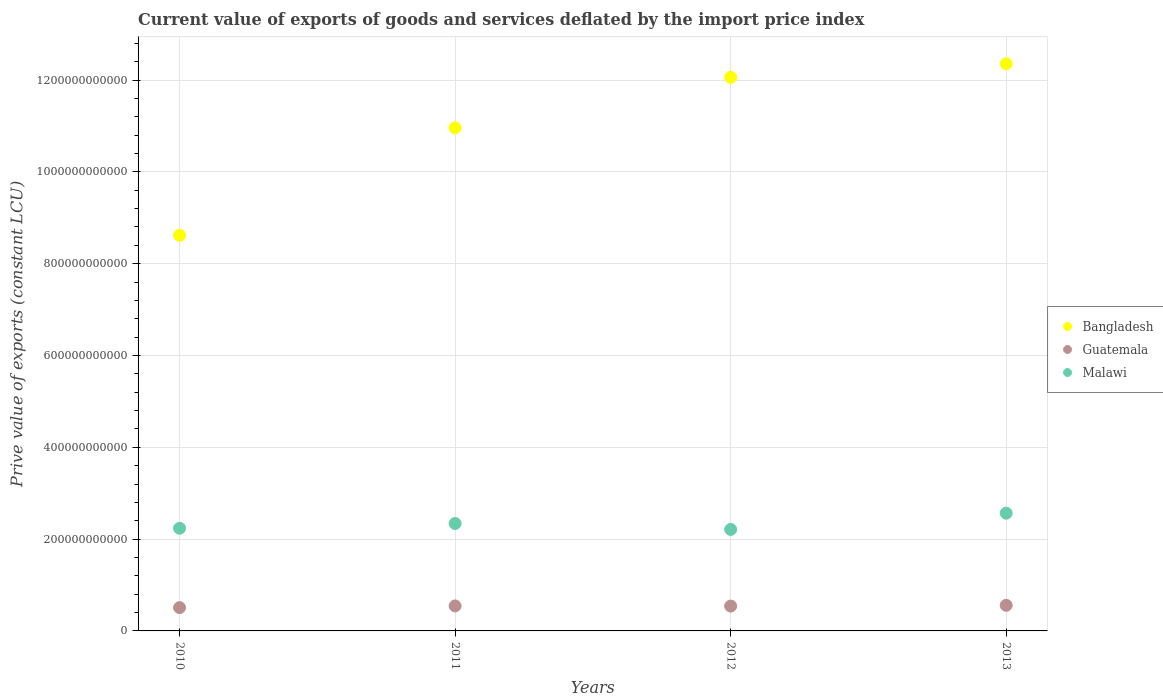How many different coloured dotlines are there?
Offer a terse response. 3. What is the prive value of exports in Malawi in 2012?
Your answer should be compact. 2.21e+11. Across all years, what is the maximum prive value of exports in Bangladesh?
Ensure brevity in your answer.  1.24e+12. Across all years, what is the minimum prive value of exports in Malawi?
Give a very brief answer. 2.21e+11. What is the total prive value of exports in Bangladesh in the graph?
Provide a short and direct response. 4.40e+12. What is the difference between the prive value of exports in Bangladesh in 2010 and that in 2012?
Give a very brief answer. -3.44e+11. What is the difference between the prive value of exports in Guatemala in 2013 and the prive value of exports in Bangladesh in 2010?
Give a very brief answer. -8.06e+11. What is the average prive value of exports in Guatemala per year?
Ensure brevity in your answer.  5.38e+1. In the year 2012, what is the difference between the prive value of exports in Malawi and prive value of exports in Guatemala?
Your answer should be compact. 1.67e+11. What is the ratio of the prive value of exports in Guatemala in 2012 to that in 2013?
Offer a very short reply. 0.97. What is the difference between the highest and the second highest prive value of exports in Guatemala?
Keep it short and to the point. 1.31e+09. What is the difference between the highest and the lowest prive value of exports in Bangladesh?
Your response must be concise. 3.74e+11. Is the sum of the prive value of exports in Guatemala in 2012 and 2013 greater than the maximum prive value of exports in Malawi across all years?
Your answer should be compact. No. Is it the case that in every year, the sum of the prive value of exports in Bangladesh and prive value of exports in Guatemala  is greater than the prive value of exports in Malawi?
Your answer should be compact. Yes. Is the prive value of exports in Guatemala strictly greater than the prive value of exports in Bangladesh over the years?
Provide a short and direct response. No. Is the prive value of exports in Guatemala strictly less than the prive value of exports in Malawi over the years?
Ensure brevity in your answer.  Yes. What is the difference between two consecutive major ticks on the Y-axis?
Provide a succinct answer. 2.00e+11. Are the values on the major ticks of Y-axis written in scientific E-notation?
Offer a very short reply. No. Does the graph contain grids?
Your answer should be very brief. Yes. Where does the legend appear in the graph?
Provide a short and direct response. Center right. How many legend labels are there?
Offer a terse response. 3. What is the title of the graph?
Your answer should be compact. Current value of exports of goods and services deflated by the import price index. What is the label or title of the Y-axis?
Provide a short and direct response. Prive value of exports (constant LCU). What is the Prive value of exports (constant LCU) in Bangladesh in 2010?
Provide a short and direct response. 8.62e+11. What is the Prive value of exports (constant LCU) of Guatemala in 2010?
Ensure brevity in your answer.  5.08e+1. What is the Prive value of exports (constant LCU) of Malawi in 2010?
Offer a very short reply. 2.24e+11. What is the Prive value of exports (constant LCU) in Bangladesh in 2011?
Provide a succinct answer. 1.10e+12. What is the Prive value of exports (constant LCU) in Guatemala in 2011?
Make the answer very short. 5.45e+1. What is the Prive value of exports (constant LCU) in Malawi in 2011?
Make the answer very short. 2.34e+11. What is the Prive value of exports (constant LCU) of Bangladesh in 2012?
Ensure brevity in your answer.  1.21e+12. What is the Prive value of exports (constant LCU) of Guatemala in 2012?
Ensure brevity in your answer.  5.41e+1. What is the Prive value of exports (constant LCU) of Malawi in 2012?
Your answer should be compact. 2.21e+11. What is the Prive value of exports (constant LCU) in Bangladesh in 2013?
Make the answer very short. 1.24e+12. What is the Prive value of exports (constant LCU) of Guatemala in 2013?
Give a very brief answer. 5.58e+1. What is the Prive value of exports (constant LCU) of Malawi in 2013?
Give a very brief answer. 2.56e+11. Across all years, what is the maximum Prive value of exports (constant LCU) in Bangladesh?
Provide a succinct answer. 1.24e+12. Across all years, what is the maximum Prive value of exports (constant LCU) of Guatemala?
Provide a short and direct response. 5.58e+1. Across all years, what is the maximum Prive value of exports (constant LCU) in Malawi?
Offer a terse response. 2.56e+11. Across all years, what is the minimum Prive value of exports (constant LCU) of Bangladesh?
Your answer should be very brief. 8.62e+11. Across all years, what is the minimum Prive value of exports (constant LCU) of Guatemala?
Your answer should be compact. 5.08e+1. Across all years, what is the minimum Prive value of exports (constant LCU) in Malawi?
Your response must be concise. 2.21e+11. What is the total Prive value of exports (constant LCU) in Bangladesh in the graph?
Provide a short and direct response. 4.40e+12. What is the total Prive value of exports (constant LCU) in Guatemala in the graph?
Provide a short and direct response. 2.15e+11. What is the total Prive value of exports (constant LCU) of Malawi in the graph?
Your response must be concise. 9.35e+11. What is the difference between the Prive value of exports (constant LCU) of Bangladesh in 2010 and that in 2011?
Provide a short and direct response. -2.34e+11. What is the difference between the Prive value of exports (constant LCU) in Guatemala in 2010 and that in 2011?
Provide a succinct answer. -3.71e+09. What is the difference between the Prive value of exports (constant LCU) of Malawi in 2010 and that in 2011?
Your answer should be very brief. -1.03e+1. What is the difference between the Prive value of exports (constant LCU) in Bangladesh in 2010 and that in 2012?
Offer a terse response. -3.44e+11. What is the difference between the Prive value of exports (constant LCU) of Guatemala in 2010 and that in 2012?
Ensure brevity in your answer.  -3.33e+09. What is the difference between the Prive value of exports (constant LCU) in Malawi in 2010 and that in 2012?
Provide a succinct answer. 2.58e+09. What is the difference between the Prive value of exports (constant LCU) of Bangladesh in 2010 and that in 2013?
Provide a short and direct response. -3.74e+11. What is the difference between the Prive value of exports (constant LCU) in Guatemala in 2010 and that in 2013?
Your answer should be very brief. -5.02e+09. What is the difference between the Prive value of exports (constant LCU) of Malawi in 2010 and that in 2013?
Your answer should be compact. -3.28e+1. What is the difference between the Prive value of exports (constant LCU) of Bangladesh in 2011 and that in 2012?
Your answer should be compact. -1.10e+11. What is the difference between the Prive value of exports (constant LCU) of Guatemala in 2011 and that in 2012?
Make the answer very short. 3.71e+08. What is the difference between the Prive value of exports (constant LCU) of Malawi in 2011 and that in 2012?
Provide a short and direct response. 1.29e+1. What is the difference between the Prive value of exports (constant LCU) in Bangladesh in 2011 and that in 2013?
Your response must be concise. -1.40e+11. What is the difference between the Prive value of exports (constant LCU) in Guatemala in 2011 and that in 2013?
Your answer should be very brief. -1.31e+09. What is the difference between the Prive value of exports (constant LCU) in Malawi in 2011 and that in 2013?
Your answer should be very brief. -2.24e+1. What is the difference between the Prive value of exports (constant LCU) in Bangladesh in 2012 and that in 2013?
Provide a succinct answer. -2.96e+1. What is the difference between the Prive value of exports (constant LCU) of Guatemala in 2012 and that in 2013?
Your answer should be very brief. -1.68e+09. What is the difference between the Prive value of exports (constant LCU) of Malawi in 2012 and that in 2013?
Offer a terse response. -3.54e+1. What is the difference between the Prive value of exports (constant LCU) of Bangladesh in 2010 and the Prive value of exports (constant LCU) of Guatemala in 2011?
Make the answer very short. 8.07e+11. What is the difference between the Prive value of exports (constant LCU) in Bangladesh in 2010 and the Prive value of exports (constant LCU) in Malawi in 2011?
Give a very brief answer. 6.28e+11. What is the difference between the Prive value of exports (constant LCU) in Guatemala in 2010 and the Prive value of exports (constant LCU) in Malawi in 2011?
Offer a terse response. -1.83e+11. What is the difference between the Prive value of exports (constant LCU) of Bangladesh in 2010 and the Prive value of exports (constant LCU) of Guatemala in 2012?
Provide a short and direct response. 8.08e+11. What is the difference between the Prive value of exports (constant LCU) of Bangladesh in 2010 and the Prive value of exports (constant LCU) of Malawi in 2012?
Give a very brief answer. 6.41e+11. What is the difference between the Prive value of exports (constant LCU) in Guatemala in 2010 and the Prive value of exports (constant LCU) in Malawi in 2012?
Provide a short and direct response. -1.70e+11. What is the difference between the Prive value of exports (constant LCU) in Bangladesh in 2010 and the Prive value of exports (constant LCU) in Guatemala in 2013?
Keep it short and to the point. 8.06e+11. What is the difference between the Prive value of exports (constant LCU) of Bangladesh in 2010 and the Prive value of exports (constant LCU) of Malawi in 2013?
Offer a terse response. 6.05e+11. What is the difference between the Prive value of exports (constant LCU) in Guatemala in 2010 and the Prive value of exports (constant LCU) in Malawi in 2013?
Keep it short and to the point. -2.06e+11. What is the difference between the Prive value of exports (constant LCU) in Bangladesh in 2011 and the Prive value of exports (constant LCU) in Guatemala in 2012?
Offer a terse response. 1.04e+12. What is the difference between the Prive value of exports (constant LCU) of Bangladesh in 2011 and the Prive value of exports (constant LCU) of Malawi in 2012?
Provide a short and direct response. 8.75e+11. What is the difference between the Prive value of exports (constant LCU) in Guatemala in 2011 and the Prive value of exports (constant LCU) in Malawi in 2012?
Provide a short and direct response. -1.67e+11. What is the difference between the Prive value of exports (constant LCU) in Bangladesh in 2011 and the Prive value of exports (constant LCU) in Guatemala in 2013?
Ensure brevity in your answer.  1.04e+12. What is the difference between the Prive value of exports (constant LCU) of Bangladesh in 2011 and the Prive value of exports (constant LCU) of Malawi in 2013?
Offer a very short reply. 8.39e+11. What is the difference between the Prive value of exports (constant LCU) in Guatemala in 2011 and the Prive value of exports (constant LCU) in Malawi in 2013?
Your response must be concise. -2.02e+11. What is the difference between the Prive value of exports (constant LCU) of Bangladesh in 2012 and the Prive value of exports (constant LCU) of Guatemala in 2013?
Ensure brevity in your answer.  1.15e+12. What is the difference between the Prive value of exports (constant LCU) of Bangladesh in 2012 and the Prive value of exports (constant LCU) of Malawi in 2013?
Offer a very short reply. 9.49e+11. What is the difference between the Prive value of exports (constant LCU) of Guatemala in 2012 and the Prive value of exports (constant LCU) of Malawi in 2013?
Provide a short and direct response. -2.02e+11. What is the average Prive value of exports (constant LCU) of Bangladesh per year?
Your answer should be compact. 1.10e+12. What is the average Prive value of exports (constant LCU) in Guatemala per year?
Your answer should be very brief. 5.38e+1. What is the average Prive value of exports (constant LCU) of Malawi per year?
Ensure brevity in your answer.  2.34e+11. In the year 2010, what is the difference between the Prive value of exports (constant LCU) in Bangladesh and Prive value of exports (constant LCU) in Guatemala?
Offer a terse response. 8.11e+11. In the year 2010, what is the difference between the Prive value of exports (constant LCU) in Bangladesh and Prive value of exports (constant LCU) in Malawi?
Ensure brevity in your answer.  6.38e+11. In the year 2010, what is the difference between the Prive value of exports (constant LCU) in Guatemala and Prive value of exports (constant LCU) in Malawi?
Your answer should be compact. -1.73e+11. In the year 2011, what is the difference between the Prive value of exports (constant LCU) of Bangladesh and Prive value of exports (constant LCU) of Guatemala?
Make the answer very short. 1.04e+12. In the year 2011, what is the difference between the Prive value of exports (constant LCU) in Bangladesh and Prive value of exports (constant LCU) in Malawi?
Provide a short and direct response. 8.62e+11. In the year 2011, what is the difference between the Prive value of exports (constant LCU) of Guatemala and Prive value of exports (constant LCU) of Malawi?
Your response must be concise. -1.80e+11. In the year 2012, what is the difference between the Prive value of exports (constant LCU) in Bangladesh and Prive value of exports (constant LCU) in Guatemala?
Offer a terse response. 1.15e+12. In the year 2012, what is the difference between the Prive value of exports (constant LCU) of Bangladesh and Prive value of exports (constant LCU) of Malawi?
Offer a terse response. 9.85e+11. In the year 2012, what is the difference between the Prive value of exports (constant LCU) in Guatemala and Prive value of exports (constant LCU) in Malawi?
Keep it short and to the point. -1.67e+11. In the year 2013, what is the difference between the Prive value of exports (constant LCU) of Bangladesh and Prive value of exports (constant LCU) of Guatemala?
Your answer should be compact. 1.18e+12. In the year 2013, what is the difference between the Prive value of exports (constant LCU) of Bangladesh and Prive value of exports (constant LCU) of Malawi?
Provide a succinct answer. 9.79e+11. In the year 2013, what is the difference between the Prive value of exports (constant LCU) in Guatemala and Prive value of exports (constant LCU) in Malawi?
Ensure brevity in your answer.  -2.01e+11. What is the ratio of the Prive value of exports (constant LCU) in Bangladesh in 2010 to that in 2011?
Provide a short and direct response. 0.79. What is the ratio of the Prive value of exports (constant LCU) in Guatemala in 2010 to that in 2011?
Your response must be concise. 0.93. What is the ratio of the Prive value of exports (constant LCU) of Malawi in 2010 to that in 2011?
Offer a terse response. 0.96. What is the ratio of the Prive value of exports (constant LCU) of Bangladesh in 2010 to that in 2012?
Provide a succinct answer. 0.71. What is the ratio of the Prive value of exports (constant LCU) in Guatemala in 2010 to that in 2012?
Give a very brief answer. 0.94. What is the ratio of the Prive value of exports (constant LCU) of Malawi in 2010 to that in 2012?
Provide a succinct answer. 1.01. What is the ratio of the Prive value of exports (constant LCU) in Bangladesh in 2010 to that in 2013?
Offer a very short reply. 0.7. What is the ratio of the Prive value of exports (constant LCU) of Guatemala in 2010 to that in 2013?
Offer a very short reply. 0.91. What is the ratio of the Prive value of exports (constant LCU) in Malawi in 2010 to that in 2013?
Your answer should be compact. 0.87. What is the ratio of the Prive value of exports (constant LCU) of Bangladesh in 2011 to that in 2012?
Keep it short and to the point. 0.91. What is the ratio of the Prive value of exports (constant LCU) of Malawi in 2011 to that in 2012?
Your response must be concise. 1.06. What is the ratio of the Prive value of exports (constant LCU) in Bangladesh in 2011 to that in 2013?
Your response must be concise. 0.89. What is the ratio of the Prive value of exports (constant LCU) of Guatemala in 2011 to that in 2013?
Provide a succinct answer. 0.98. What is the ratio of the Prive value of exports (constant LCU) of Malawi in 2011 to that in 2013?
Provide a succinct answer. 0.91. What is the ratio of the Prive value of exports (constant LCU) in Bangladesh in 2012 to that in 2013?
Your answer should be very brief. 0.98. What is the ratio of the Prive value of exports (constant LCU) of Guatemala in 2012 to that in 2013?
Your answer should be compact. 0.97. What is the ratio of the Prive value of exports (constant LCU) in Malawi in 2012 to that in 2013?
Offer a terse response. 0.86. What is the difference between the highest and the second highest Prive value of exports (constant LCU) of Bangladesh?
Ensure brevity in your answer.  2.96e+1. What is the difference between the highest and the second highest Prive value of exports (constant LCU) in Guatemala?
Your response must be concise. 1.31e+09. What is the difference between the highest and the second highest Prive value of exports (constant LCU) in Malawi?
Provide a succinct answer. 2.24e+1. What is the difference between the highest and the lowest Prive value of exports (constant LCU) in Bangladesh?
Make the answer very short. 3.74e+11. What is the difference between the highest and the lowest Prive value of exports (constant LCU) of Guatemala?
Offer a terse response. 5.02e+09. What is the difference between the highest and the lowest Prive value of exports (constant LCU) of Malawi?
Offer a very short reply. 3.54e+1. 